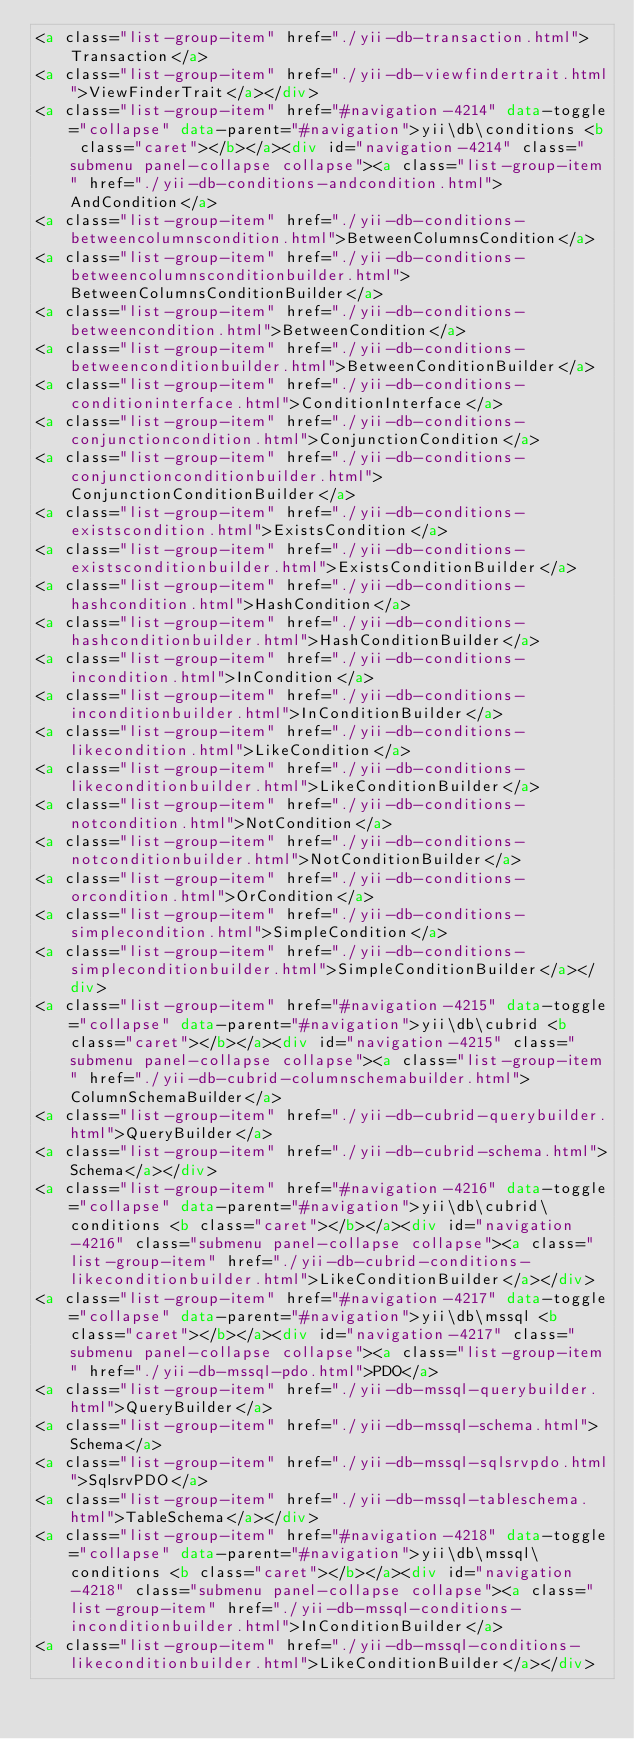<code> <loc_0><loc_0><loc_500><loc_500><_HTML_><a class="list-group-item" href="./yii-db-transaction.html">Transaction</a>
<a class="list-group-item" href="./yii-db-viewfindertrait.html">ViewFinderTrait</a></div>
<a class="list-group-item" href="#navigation-4214" data-toggle="collapse" data-parent="#navigation">yii\db\conditions <b class="caret"></b></a><div id="navigation-4214" class="submenu panel-collapse collapse"><a class="list-group-item" href="./yii-db-conditions-andcondition.html">AndCondition</a>
<a class="list-group-item" href="./yii-db-conditions-betweencolumnscondition.html">BetweenColumnsCondition</a>
<a class="list-group-item" href="./yii-db-conditions-betweencolumnsconditionbuilder.html">BetweenColumnsConditionBuilder</a>
<a class="list-group-item" href="./yii-db-conditions-betweencondition.html">BetweenCondition</a>
<a class="list-group-item" href="./yii-db-conditions-betweenconditionbuilder.html">BetweenConditionBuilder</a>
<a class="list-group-item" href="./yii-db-conditions-conditioninterface.html">ConditionInterface</a>
<a class="list-group-item" href="./yii-db-conditions-conjunctioncondition.html">ConjunctionCondition</a>
<a class="list-group-item" href="./yii-db-conditions-conjunctionconditionbuilder.html">ConjunctionConditionBuilder</a>
<a class="list-group-item" href="./yii-db-conditions-existscondition.html">ExistsCondition</a>
<a class="list-group-item" href="./yii-db-conditions-existsconditionbuilder.html">ExistsConditionBuilder</a>
<a class="list-group-item" href="./yii-db-conditions-hashcondition.html">HashCondition</a>
<a class="list-group-item" href="./yii-db-conditions-hashconditionbuilder.html">HashConditionBuilder</a>
<a class="list-group-item" href="./yii-db-conditions-incondition.html">InCondition</a>
<a class="list-group-item" href="./yii-db-conditions-inconditionbuilder.html">InConditionBuilder</a>
<a class="list-group-item" href="./yii-db-conditions-likecondition.html">LikeCondition</a>
<a class="list-group-item" href="./yii-db-conditions-likeconditionbuilder.html">LikeConditionBuilder</a>
<a class="list-group-item" href="./yii-db-conditions-notcondition.html">NotCondition</a>
<a class="list-group-item" href="./yii-db-conditions-notconditionbuilder.html">NotConditionBuilder</a>
<a class="list-group-item" href="./yii-db-conditions-orcondition.html">OrCondition</a>
<a class="list-group-item" href="./yii-db-conditions-simplecondition.html">SimpleCondition</a>
<a class="list-group-item" href="./yii-db-conditions-simpleconditionbuilder.html">SimpleConditionBuilder</a></div>
<a class="list-group-item" href="#navigation-4215" data-toggle="collapse" data-parent="#navigation">yii\db\cubrid <b class="caret"></b></a><div id="navigation-4215" class="submenu panel-collapse collapse"><a class="list-group-item" href="./yii-db-cubrid-columnschemabuilder.html">ColumnSchemaBuilder</a>
<a class="list-group-item" href="./yii-db-cubrid-querybuilder.html">QueryBuilder</a>
<a class="list-group-item" href="./yii-db-cubrid-schema.html">Schema</a></div>
<a class="list-group-item" href="#navigation-4216" data-toggle="collapse" data-parent="#navigation">yii\db\cubrid\conditions <b class="caret"></b></a><div id="navigation-4216" class="submenu panel-collapse collapse"><a class="list-group-item" href="./yii-db-cubrid-conditions-likeconditionbuilder.html">LikeConditionBuilder</a></div>
<a class="list-group-item" href="#navigation-4217" data-toggle="collapse" data-parent="#navigation">yii\db\mssql <b class="caret"></b></a><div id="navigation-4217" class="submenu panel-collapse collapse"><a class="list-group-item" href="./yii-db-mssql-pdo.html">PDO</a>
<a class="list-group-item" href="./yii-db-mssql-querybuilder.html">QueryBuilder</a>
<a class="list-group-item" href="./yii-db-mssql-schema.html">Schema</a>
<a class="list-group-item" href="./yii-db-mssql-sqlsrvpdo.html">SqlsrvPDO</a>
<a class="list-group-item" href="./yii-db-mssql-tableschema.html">TableSchema</a></div>
<a class="list-group-item" href="#navigation-4218" data-toggle="collapse" data-parent="#navigation">yii\db\mssql\conditions <b class="caret"></b></a><div id="navigation-4218" class="submenu panel-collapse collapse"><a class="list-group-item" href="./yii-db-mssql-conditions-inconditionbuilder.html">InConditionBuilder</a>
<a class="list-group-item" href="./yii-db-mssql-conditions-likeconditionbuilder.html">LikeConditionBuilder</a></div></code> 